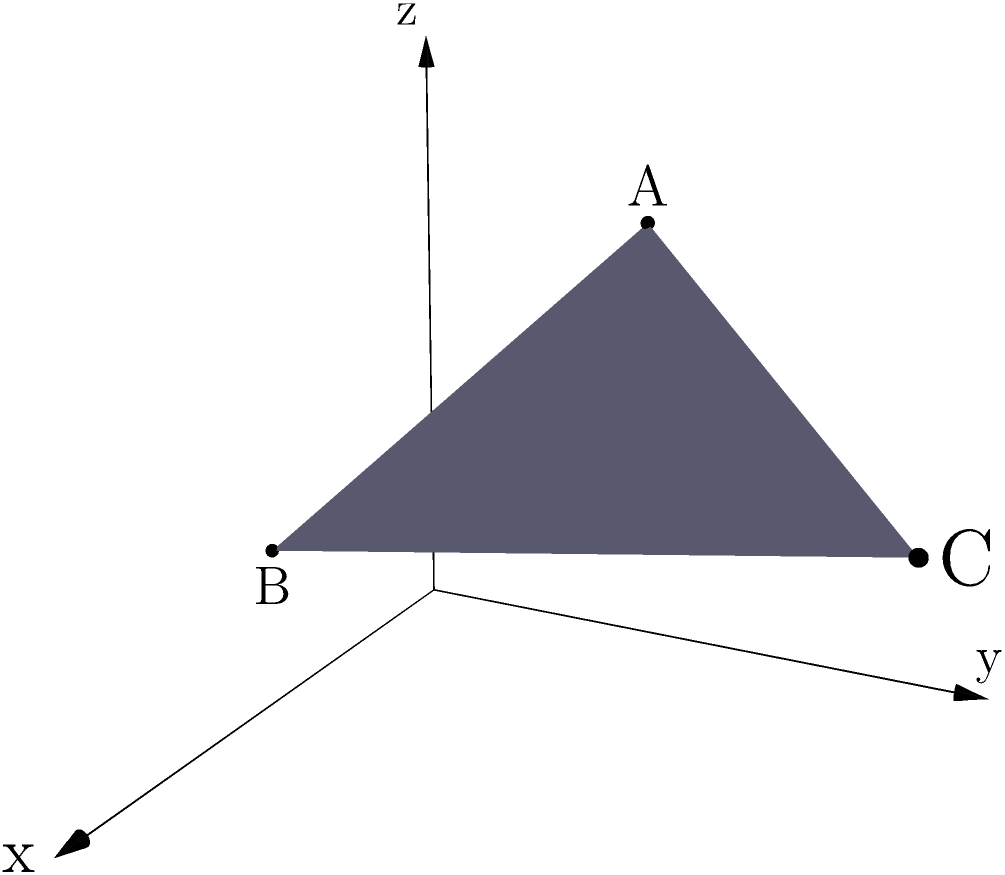As a computer technician troubleshooting file transfer issues, you need to visualize data points in 3D space. Given three points A(1,2,3), B(2,0,1), and C(3,4,2) representing server locations, find the equation of the plane passing through these points. This could help in understanding the spatial relationship of data transfer paths. To find the equation of a plane passing through three points, we can follow these steps:

1) The general equation of a plane is $Ax + By + Cz + D = 0$.

2) We can find the normal vector to the plane using the cross product of two vectors on the plane:
   $\vec{AB} = (2-1, 0-2, 1-3) = (1, -2, -2)$
   $\vec{AC} = (3-1, 4-2, 2-3) = (2, 2, -1)$

3) The normal vector $\vec{n} = \vec{AB} \times \vec{AC}$:
   $\vec{n} = ((-2)(-1) - (-2)(2), (-2)(2) - (1)(-1), (1)(2) - (-2)(2))$
   $\vec{n} = (2 - (-4), -4 - (-1), 2 - (-4))$
   $\vec{n} = (6, -3, 6)$

4) So, the equation of the plane is:
   $6x - 3y + 6z + D = 0$

5) To find D, we can substitute the coordinates of any of the given points. Let's use A(1,2,3):
   $6(1) - 3(2) + 6(3) + D = 0$
   $6 - 6 + 18 + D = 0$
   $18 + D = 0$
   $D = -18$

6) Therefore, the final equation of the plane is:
   $6x - 3y + 6z - 18 = 0$

We can simplify this by dividing everything by 3:
$2x - y + 2z - 6 = 0$
Answer: $2x - y + 2z - 6 = 0$ 